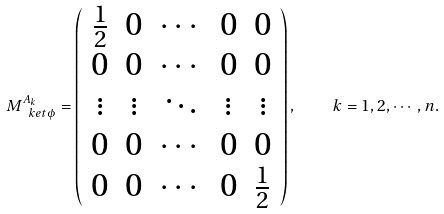<formula> <loc_0><loc_0><loc_500><loc_500>M _ { \ k e t { \phi } } ^ { A _ { k } } = \left ( \begin{array} { c c c c c } { \frac { 1 } { 2 } } & 0 & \cdots & 0 & 0 \\ 0 & 0 & \cdots & 0 & 0 \\ \vdots & \vdots & \ddots & \vdots & \vdots \\ 0 & 0 & \cdots & 0 & 0 \\ 0 & 0 & \cdots & 0 & { \frac { 1 } { 2 } } \end{array} \right ) , \quad k = 1 , 2 , \cdots , n .</formula> 